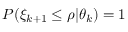Convert formula to latex. <formula><loc_0><loc_0><loc_500><loc_500>P ( \xi _ { k + 1 } \leq \rho | \theta _ { k } ) = 1</formula> 